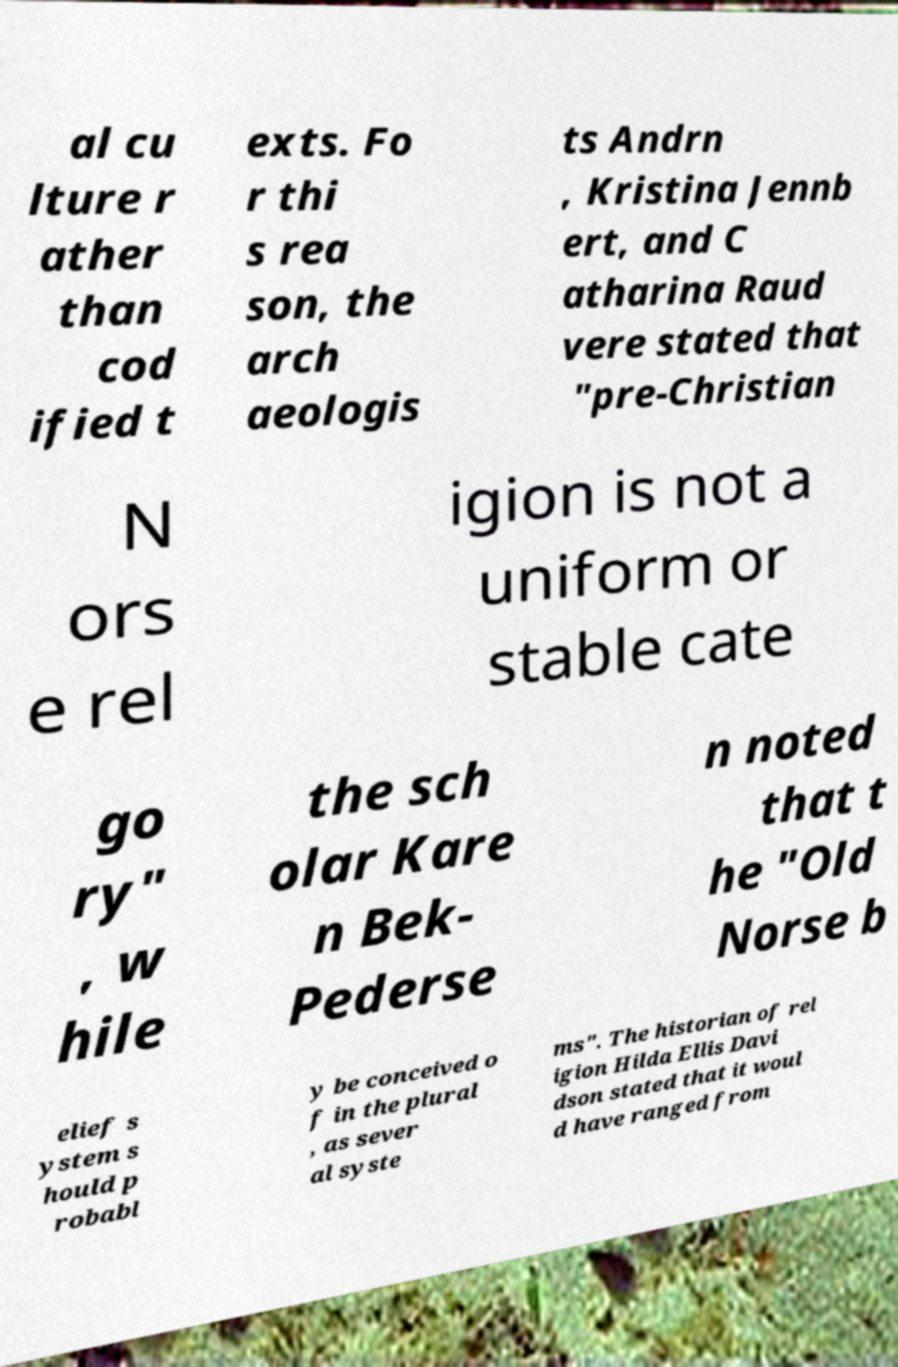Can you read and provide the text displayed in the image?This photo seems to have some interesting text. Can you extract and type it out for me? al cu lture r ather than cod ified t exts. Fo r thi s rea son, the arch aeologis ts Andrn , Kristina Jennb ert, and C atharina Raud vere stated that "pre-Christian N ors e rel igion is not a uniform or stable cate go ry" , w hile the sch olar Kare n Bek- Pederse n noted that t he "Old Norse b elief s ystem s hould p robabl y be conceived o f in the plural , as sever al syste ms". The historian of rel igion Hilda Ellis Davi dson stated that it woul d have ranged from 